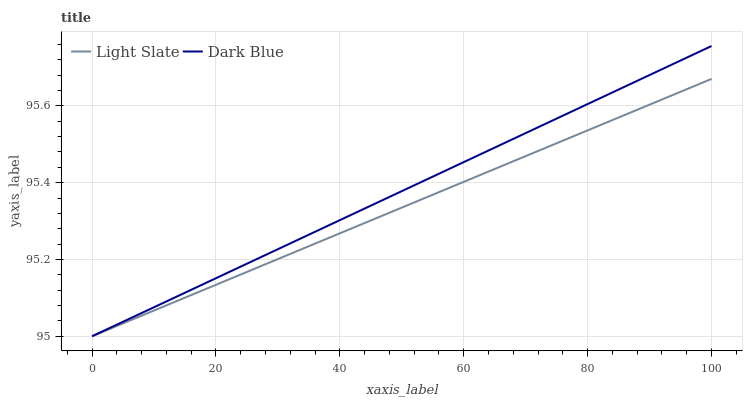Does Dark Blue have the minimum area under the curve?
Answer yes or no. No. Is Dark Blue the roughest?
Answer yes or no. No. 